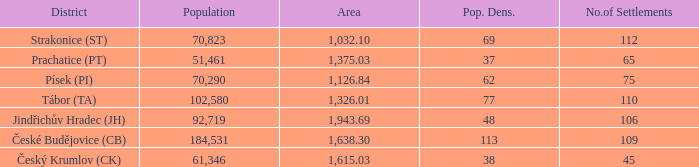How big is the area that has a population density of 113 and a population larger than 184,531? 0.0. 